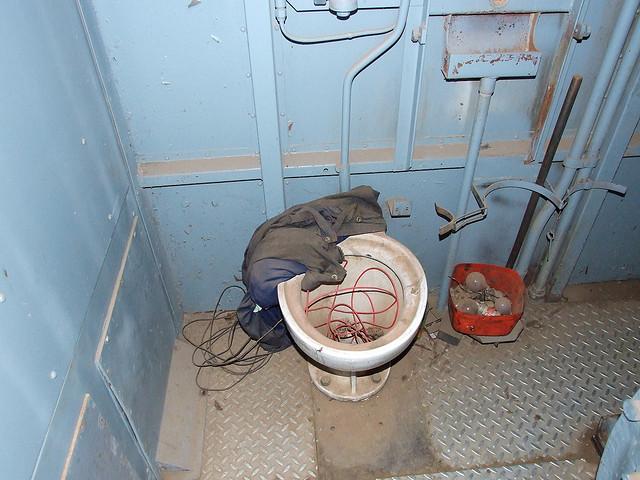What is leaning on the toilet?
Quick response, please. Jacket. Are wires visible?
Short answer required. Yes. What type of metal is the flooring?
Answer briefly. Steel. What color is the room?
Be succinct. Blue. 